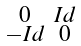<formula> <loc_0><loc_0><loc_500><loc_500>\begin{smallmatrix} 0 & I d \\ - I d & 0 \end{smallmatrix}</formula> 